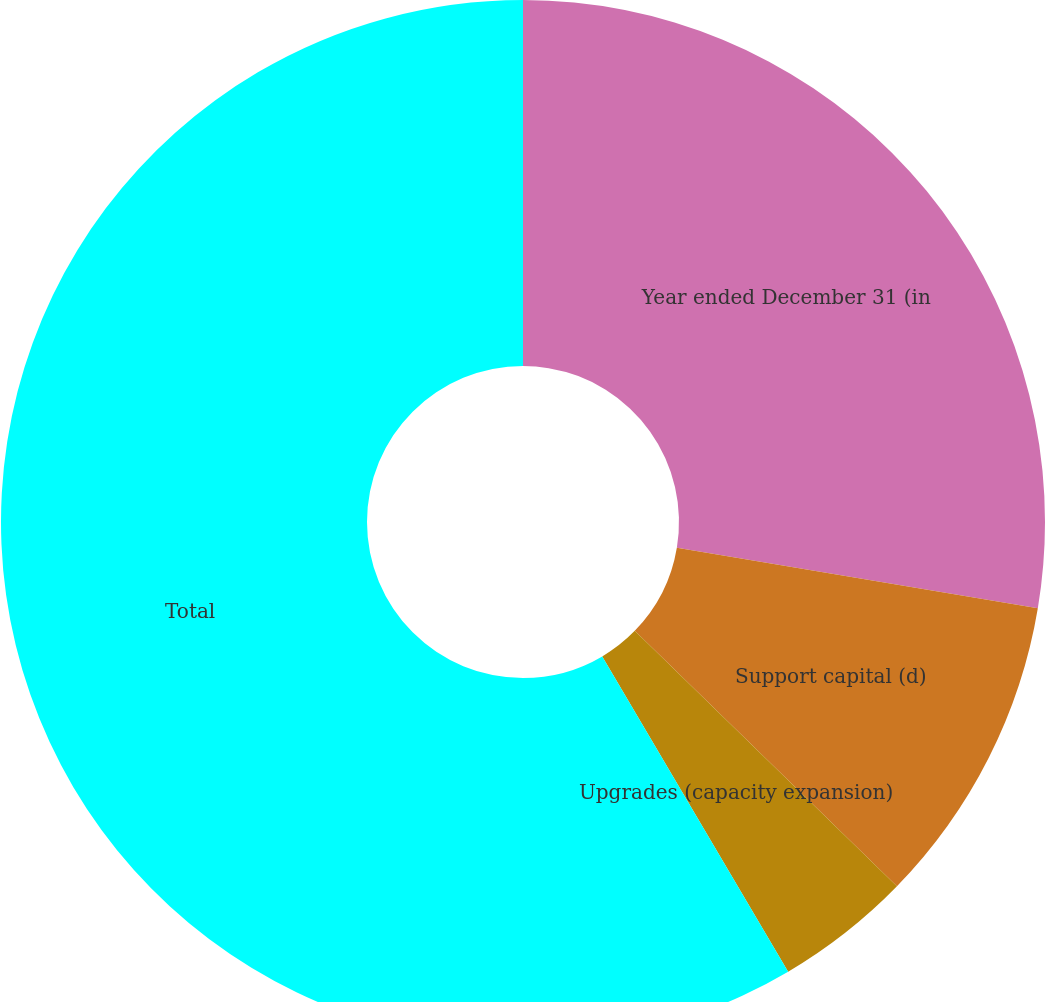Convert chart. <chart><loc_0><loc_0><loc_500><loc_500><pie_chart><fcel>Year ended December 31 (in<fcel>Support capital (d)<fcel>Upgrades (capacity expansion)<fcel>Total<nl><fcel>27.64%<fcel>9.65%<fcel>4.23%<fcel>58.48%<nl></chart> 